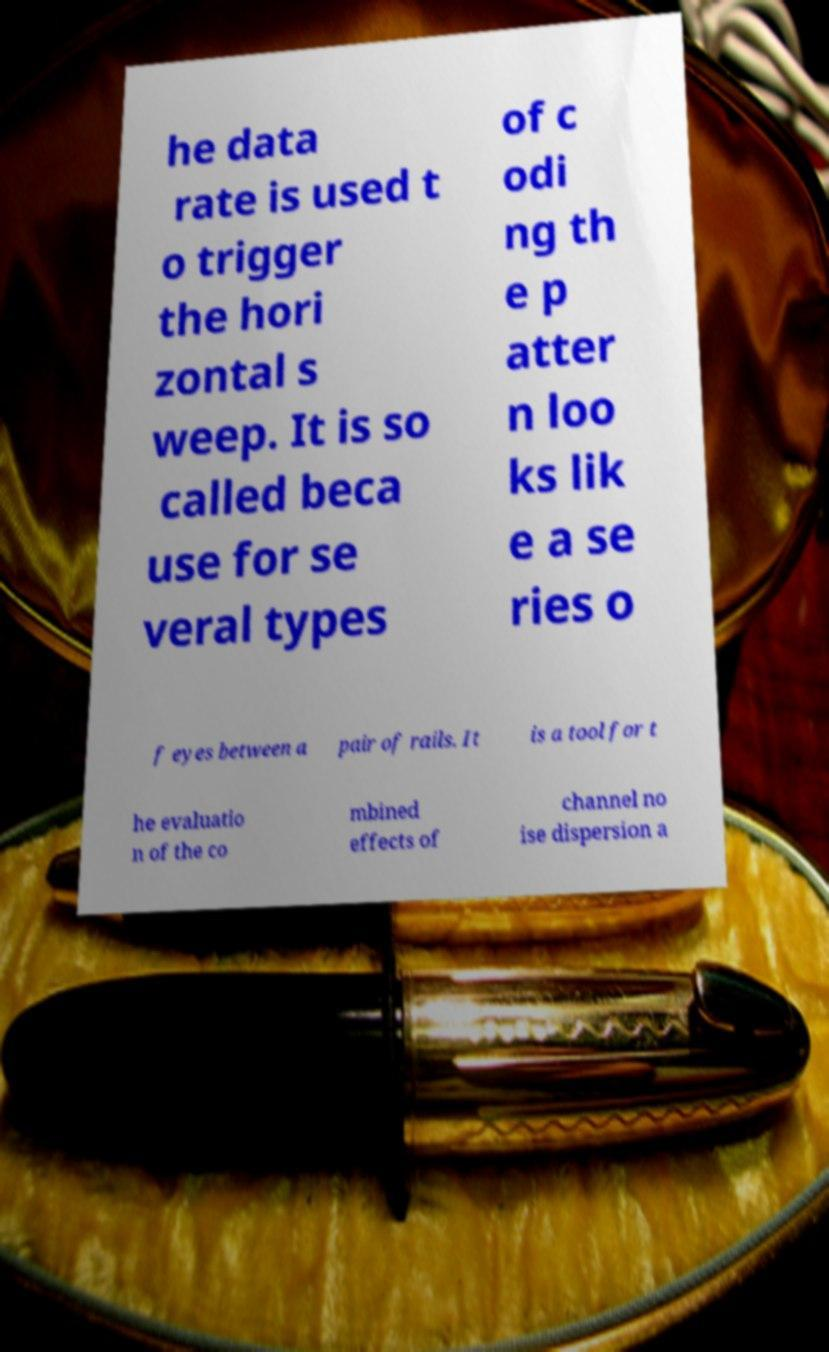Could you extract and type out the text from this image? he data rate is used t o trigger the hori zontal s weep. It is so called beca use for se veral types of c odi ng th e p atter n loo ks lik e a se ries o f eyes between a pair of rails. It is a tool for t he evaluatio n of the co mbined effects of channel no ise dispersion a 